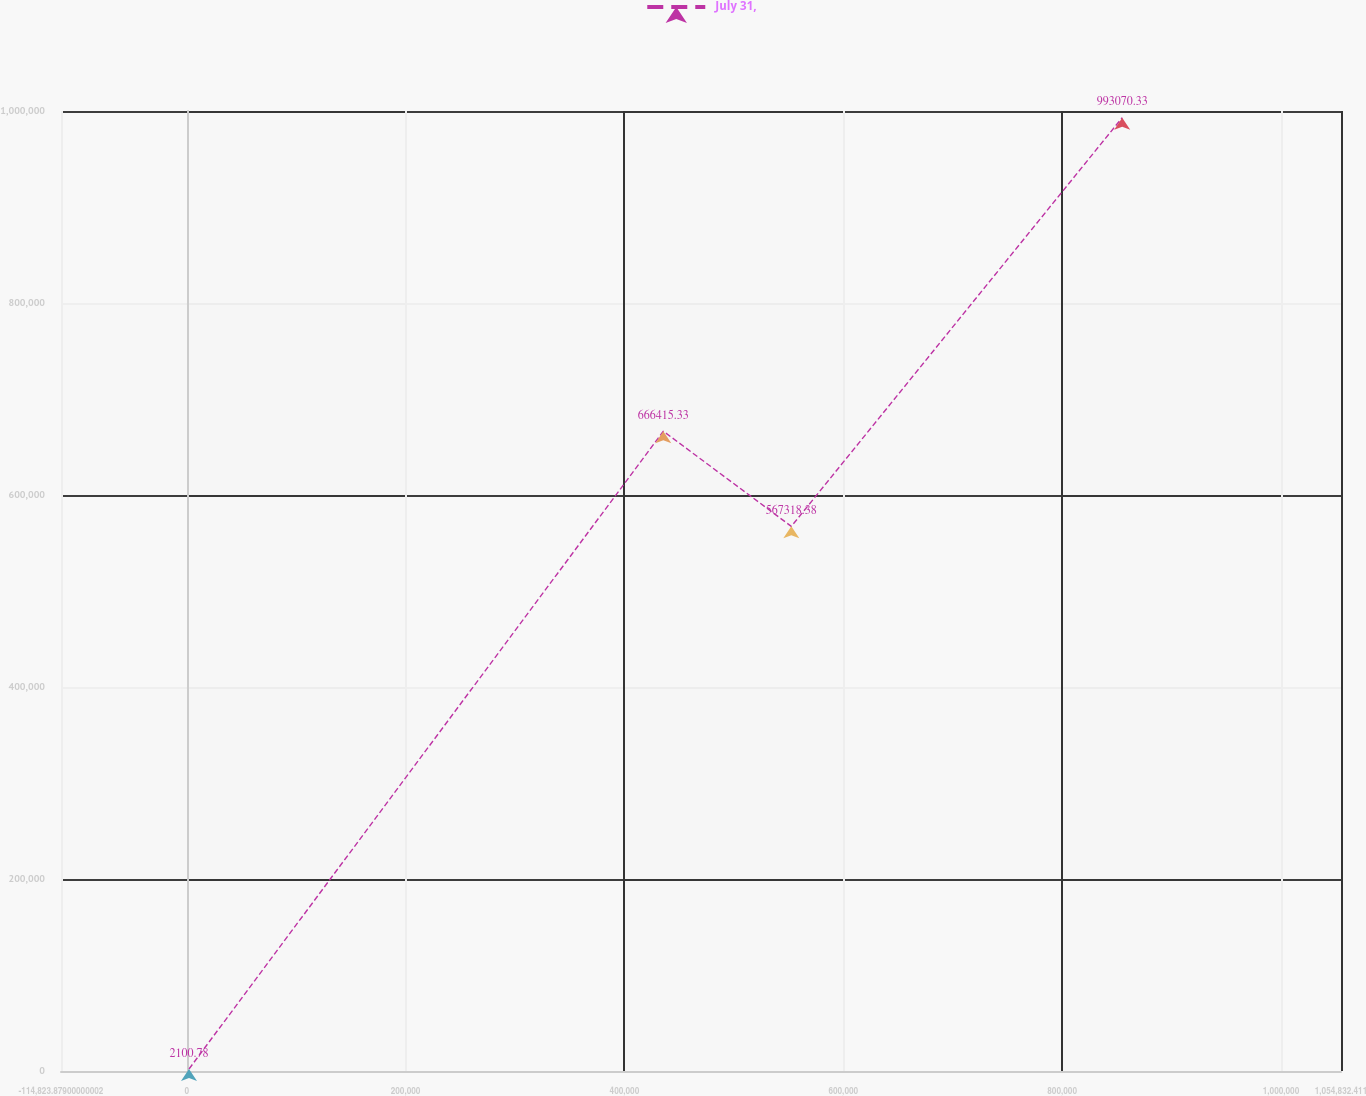Convert chart to OTSL. <chart><loc_0><loc_0><loc_500><loc_500><line_chart><ecel><fcel>July 31,<nl><fcel>2141.75<fcel>2100.78<nl><fcel>435583<fcel>666415<nl><fcel>552549<fcel>567318<nl><fcel>854902<fcel>993070<nl><fcel>1.1718e+06<fcel>841870<nl></chart> 